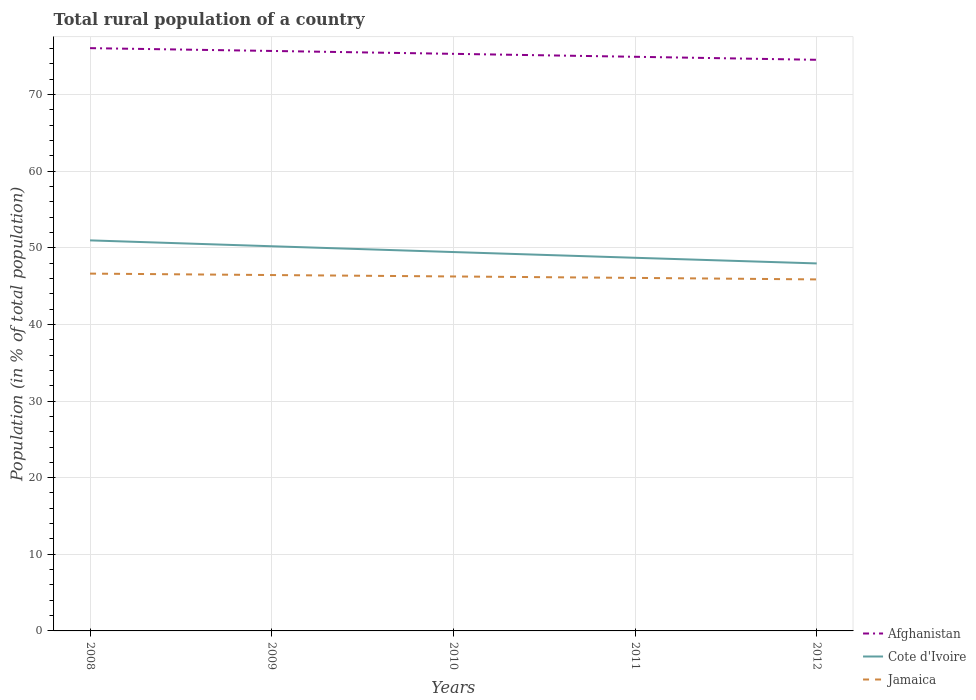How many different coloured lines are there?
Give a very brief answer. 3. Across all years, what is the maximum rural population in Jamaica?
Provide a succinct answer. 45.87. In which year was the rural population in Cote d'Ivoire maximum?
Offer a very short reply. 2012. What is the total rural population in Cote d'Ivoire in the graph?
Make the answer very short. 1.52. What is the difference between the highest and the second highest rural population in Cote d'Ivoire?
Keep it short and to the point. 3.01. Is the rural population in Cote d'Ivoire strictly greater than the rural population in Jamaica over the years?
Ensure brevity in your answer.  No. How many years are there in the graph?
Offer a terse response. 5. Are the values on the major ticks of Y-axis written in scientific E-notation?
Give a very brief answer. No. Does the graph contain grids?
Keep it short and to the point. Yes. How many legend labels are there?
Provide a succinct answer. 3. What is the title of the graph?
Ensure brevity in your answer.  Total rural population of a country. Does "Barbados" appear as one of the legend labels in the graph?
Offer a very short reply. No. What is the label or title of the X-axis?
Give a very brief answer. Years. What is the label or title of the Y-axis?
Your response must be concise. Population (in % of total population). What is the Population (in % of total population) of Afghanistan in 2008?
Give a very brief answer. 76.05. What is the Population (in % of total population) in Cote d'Ivoire in 2008?
Offer a terse response. 50.97. What is the Population (in % of total population) in Jamaica in 2008?
Provide a succinct answer. 46.63. What is the Population (in % of total population) of Afghanistan in 2009?
Make the answer very short. 75.69. What is the Population (in % of total population) in Cote d'Ivoire in 2009?
Keep it short and to the point. 50.2. What is the Population (in % of total population) of Jamaica in 2009?
Keep it short and to the point. 46.44. What is the Population (in % of total population) of Afghanistan in 2010?
Your answer should be very brief. 75.31. What is the Population (in % of total population) of Cote d'Ivoire in 2010?
Give a very brief answer. 49.44. What is the Population (in % of total population) of Jamaica in 2010?
Give a very brief answer. 46.26. What is the Population (in % of total population) in Afghanistan in 2011?
Offer a terse response. 74.93. What is the Population (in % of total population) in Cote d'Ivoire in 2011?
Keep it short and to the point. 48.7. What is the Population (in % of total population) of Jamaica in 2011?
Ensure brevity in your answer.  46.07. What is the Population (in % of total population) of Afghanistan in 2012?
Your response must be concise. 74.53. What is the Population (in % of total population) of Cote d'Ivoire in 2012?
Keep it short and to the point. 47.96. What is the Population (in % of total population) of Jamaica in 2012?
Give a very brief answer. 45.87. Across all years, what is the maximum Population (in % of total population) in Afghanistan?
Your answer should be compact. 76.05. Across all years, what is the maximum Population (in % of total population) in Cote d'Ivoire?
Your response must be concise. 50.97. Across all years, what is the maximum Population (in % of total population) of Jamaica?
Your answer should be compact. 46.63. Across all years, what is the minimum Population (in % of total population) of Afghanistan?
Keep it short and to the point. 74.53. Across all years, what is the minimum Population (in % of total population) of Cote d'Ivoire?
Your answer should be compact. 47.96. Across all years, what is the minimum Population (in % of total population) of Jamaica?
Provide a succinct answer. 45.87. What is the total Population (in % of total population) of Afghanistan in the graph?
Keep it short and to the point. 376.51. What is the total Population (in % of total population) of Cote d'Ivoire in the graph?
Your answer should be compact. 247.26. What is the total Population (in % of total population) of Jamaica in the graph?
Give a very brief answer. 231.27. What is the difference between the Population (in % of total population) of Afghanistan in 2008 and that in 2009?
Your response must be concise. 0.37. What is the difference between the Population (in % of total population) of Cote d'Ivoire in 2008 and that in 2009?
Make the answer very short. 0.77. What is the difference between the Population (in % of total population) of Jamaica in 2008 and that in 2009?
Make the answer very short. 0.19. What is the difference between the Population (in % of total population) in Afghanistan in 2008 and that in 2010?
Provide a succinct answer. 0.74. What is the difference between the Population (in % of total population) of Cote d'Ivoire in 2008 and that in 2010?
Ensure brevity in your answer.  1.52. What is the difference between the Population (in % of total population) in Jamaica in 2008 and that in 2010?
Your answer should be very brief. 0.37. What is the difference between the Population (in % of total population) in Afghanistan in 2008 and that in 2011?
Ensure brevity in your answer.  1.13. What is the difference between the Population (in % of total population) of Cote d'Ivoire in 2008 and that in 2011?
Offer a terse response. 2.27. What is the difference between the Population (in % of total population) of Jamaica in 2008 and that in 2011?
Your answer should be very brief. 0.56. What is the difference between the Population (in % of total population) of Afghanistan in 2008 and that in 2012?
Your answer should be compact. 1.52. What is the difference between the Population (in % of total population) in Cote d'Ivoire in 2008 and that in 2012?
Offer a terse response. 3.01. What is the difference between the Population (in % of total population) of Jamaica in 2008 and that in 2012?
Offer a terse response. 0.76. What is the difference between the Population (in % of total population) of Afghanistan in 2009 and that in 2010?
Offer a terse response. 0.38. What is the difference between the Population (in % of total population) in Cote d'Ivoire in 2009 and that in 2010?
Your answer should be very brief. 0.76. What is the difference between the Population (in % of total population) of Jamaica in 2009 and that in 2010?
Your answer should be very brief. 0.19. What is the difference between the Population (in % of total population) of Afghanistan in 2009 and that in 2011?
Provide a short and direct response. 0.76. What is the difference between the Population (in % of total population) of Cote d'Ivoire in 2009 and that in 2011?
Offer a terse response. 1.5. What is the difference between the Population (in % of total population) in Jamaica in 2009 and that in 2011?
Keep it short and to the point. 0.37. What is the difference between the Population (in % of total population) of Afghanistan in 2009 and that in 2012?
Make the answer very short. 1.16. What is the difference between the Population (in % of total population) in Cote d'Ivoire in 2009 and that in 2012?
Your answer should be very brief. 2.24. What is the difference between the Population (in % of total population) of Jamaica in 2009 and that in 2012?
Your response must be concise. 0.57. What is the difference between the Population (in % of total population) of Afghanistan in 2010 and that in 2011?
Make the answer very short. 0.39. What is the difference between the Population (in % of total population) in Cote d'Ivoire in 2010 and that in 2011?
Provide a succinct answer. 0.75. What is the difference between the Population (in % of total population) in Jamaica in 2010 and that in 2011?
Give a very brief answer. 0.19. What is the difference between the Population (in % of total population) of Afghanistan in 2010 and that in 2012?
Your response must be concise. 0.78. What is the difference between the Population (in % of total population) in Cote d'Ivoire in 2010 and that in 2012?
Provide a short and direct response. 1.48. What is the difference between the Population (in % of total population) of Jamaica in 2010 and that in 2012?
Offer a terse response. 0.38. What is the difference between the Population (in % of total population) of Afghanistan in 2011 and that in 2012?
Ensure brevity in your answer.  0.39. What is the difference between the Population (in % of total population) of Cote d'Ivoire in 2011 and that in 2012?
Offer a very short reply. 0.74. What is the difference between the Population (in % of total population) of Jamaica in 2011 and that in 2012?
Keep it short and to the point. 0.2. What is the difference between the Population (in % of total population) of Afghanistan in 2008 and the Population (in % of total population) of Cote d'Ivoire in 2009?
Offer a very short reply. 25.85. What is the difference between the Population (in % of total population) of Afghanistan in 2008 and the Population (in % of total population) of Jamaica in 2009?
Provide a short and direct response. 29.61. What is the difference between the Population (in % of total population) of Cote d'Ivoire in 2008 and the Population (in % of total population) of Jamaica in 2009?
Ensure brevity in your answer.  4.52. What is the difference between the Population (in % of total population) of Afghanistan in 2008 and the Population (in % of total population) of Cote d'Ivoire in 2010?
Your answer should be very brief. 26.61. What is the difference between the Population (in % of total population) of Afghanistan in 2008 and the Population (in % of total population) of Jamaica in 2010?
Your answer should be very brief. 29.8. What is the difference between the Population (in % of total population) in Cote d'Ivoire in 2008 and the Population (in % of total population) in Jamaica in 2010?
Your answer should be very brief. 4.71. What is the difference between the Population (in % of total population) in Afghanistan in 2008 and the Population (in % of total population) in Cote d'Ivoire in 2011?
Offer a terse response. 27.36. What is the difference between the Population (in % of total population) in Afghanistan in 2008 and the Population (in % of total population) in Jamaica in 2011?
Keep it short and to the point. 29.98. What is the difference between the Population (in % of total population) in Cote d'Ivoire in 2008 and the Population (in % of total population) in Jamaica in 2011?
Your response must be concise. 4.9. What is the difference between the Population (in % of total population) in Afghanistan in 2008 and the Population (in % of total population) in Cote d'Ivoire in 2012?
Your answer should be very brief. 28.09. What is the difference between the Population (in % of total population) of Afghanistan in 2008 and the Population (in % of total population) of Jamaica in 2012?
Keep it short and to the point. 30.18. What is the difference between the Population (in % of total population) in Cote d'Ivoire in 2008 and the Population (in % of total population) in Jamaica in 2012?
Provide a succinct answer. 5.09. What is the difference between the Population (in % of total population) of Afghanistan in 2009 and the Population (in % of total population) of Cote d'Ivoire in 2010?
Provide a short and direct response. 26.24. What is the difference between the Population (in % of total population) of Afghanistan in 2009 and the Population (in % of total population) of Jamaica in 2010?
Provide a succinct answer. 29.43. What is the difference between the Population (in % of total population) in Cote d'Ivoire in 2009 and the Population (in % of total population) in Jamaica in 2010?
Offer a very short reply. 3.94. What is the difference between the Population (in % of total population) in Afghanistan in 2009 and the Population (in % of total population) in Cote d'Ivoire in 2011?
Offer a very short reply. 26.99. What is the difference between the Population (in % of total population) of Afghanistan in 2009 and the Population (in % of total population) of Jamaica in 2011?
Your answer should be very brief. 29.62. What is the difference between the Population (in % of total population) of Cote d'Ivoire in 2009 and the Population (in % of total population) of Jamaica in 2011?
Give a very brief answer. 4.13. What is the difference between the Population (in % of total population) of Afghanistan in 2009 and the Population (in % of total population) of Cote d'Ivoire in 2012?
Offer a very short reply. 27.73. What is the difference between the Population (in % of total population) of Afghanistan in 2009 and the Population (in % of total population) of Jamaica in 2012?
Offer a very short reply. 29.81. What is the difference between the Population (in % of total population) in Cote d'Ivoire in 2009 and the Population (in % of total population) in Jamaica in 2012?
Keep it short and to the point. 4.33. What is the difference between the Population (in % of total population) of Afghanistan in 2010 and the Population (in % of total population) of Cote d'Ivoire in 2011?
Your response must be concise. 26.62. What is the difference between the Population (in % of total population) of Afghanistan in 2010 and the Population (in % of total population) of Jamaica in 2011?
Keep it short and to the point. 29.24. What is the difference between the Population (in % of total population) in Cote d'Ivoire in 2010 and the Population (in % of total population) in Jamaica in 2011?
Provide a short and direct response. 3.37. What is the difference between the Population (in % of total population) in Afghanistan in 2010 and the Population (in % of total population) in Cote d'Ivoire in 2012?
Provide a succinct answer. 27.35. What is the difference between the Population (in % of total population) in Afghanistan in 2010 and the Population (in % of total population) in Jamaica in 2012?
Your answer should be compact. 29.44. What is the difference between the Population (in % of total population) of Cote d'Ivoire in 2010 and the Population (in % of total population) of Jamaica in 2012?
Offer a very short reply. 3.57. What is the difference between the Population (in % of total population) of Afghanistan in 2011 and the Population (in % of total population) of Cote d'Ivoire in 2012?
Make the answer very short. 26.97. What is the difference between the Population (in % of total population) in Afghanistan in 2011 and the Population (in % of total population) in Jamaica in 2012?
Your answer should be very brief. 29.05. What is the difference between the Population (in % of total population) of Cote d'Ivoire in 2011 and the Population (in % of total population) of Jamaica in 2012?
Your answer should be compact. 2.82. What is the average Population (in % of total population) of Afghanistan per year?
Offer a very short reply. 75.3. What is the average Population (in % of total population) of Cote d'Ivoire per year?
Offer a very short reply. 49.45. What is the average Population (in % of total population) of Jamaica per year?
Make the answer very short. 46.25. In the year 2008, what is the difference between the Population (in % of total population) in Afghanistan and Population (in % of total population) in Cote d'Ivoire?
Make the answer very short. 25.09. In the year 2008, what is the difference between the Population (in % of total population) of Afghanistan and Population (in % of total population) of Jamaica?
Keep it short and to the point. 29.43. In the year 2008, what is the difference between the Population (in % of total population) of Cote d'Ivoire and Population (in % of total population) of Jamaica?
Give a very brief answer. 4.34. In the year 2009, what is the difference between the Population (in % of total population) in Afghanistan and Population (in % of total population) in Cote d'Ivoire?
Provide a succinct answer. 25.49. In the year 2009, what is the difference between the Population (in % of total population) of Afghanistan and Population (in % of total population) of Jamaica?
Make the answer very short. 29.24. In the year 2009, what is the difference between the Population (in % of total population) of Cote d'Ivoire and Population (in % of total population) of Jamaica?
Offer a very short reply. 3.76. In the year 2010, what is the difference between the Population (in % of total population) of Afghanistan and Population (in % of total population) of Cote d'Ivoire?
Provide a short and direct response. 25.87. In the year 2010, what is the difference between the Population (in % of total population) of Afghanistan and Population (in % of total population) of Jamaica?
Your response must be concise. 29.05. In the year 2010, what is the difference between the Population (in % of total population) of Cote d'Ivoire and Population (in % of total population) of Jamaica?
Offer a terse response. 3.19. In the year 2011, what is the difference between the Population (in % of total population) of Afghanistan and Population (in % of total population) of Cote d'Ivoire?
Ensure brevity in your answer.  26.23. In the year 2011, what is the difference between the Population (in % of total population) in Afghanistan and Population (in % of total population) in Jamaica?
Your response must be concise. 28.86. In the year 2011, what is the difference between the Population (in % of total population) in Cote d'Ivoire and Population (in % of total population) in Jamaica?
Your response must be concise. 2.62. In the year 2012, what is the difference between the Population (in % of total population) of Afghanistan and Population (in % of total population) of Cote d'Ivoire?
Ensure brevity in your answer.  26.57. In the year 2012, what is the difference between the Population (in % of total population) of Afghanistan and Population (in % of total population) of Jamaica?
Provide a short and direct response. 28.66. In the year 2012, what is the difference between the Population (in % of total population) of Cote d'Ivoire and Population (in % of total population) of Jamaica?
Provide a succinct answer. 2.09. What is the ratio of the Population (in % of total population) of Cote d'Ivoire in 2008 to that in 2009?
Provide a short and direct response. 1.02. What is the ratio of the Population (in % of total population) of Jamaica in 2008 to that in 2009?
Your answer should be compact. 1. What is the ratio of the Population (in % of total population) of Afghanistan in 2008 to that in 2010?
Your response must be concise. 1.01. What is the ratio of the Population (in % of total population) in Cote d'Ivoire in 2008 to that in 2010?
Give a very brief answer. 1.03. What is the ratio of the Population (in % of total population) in Jamaica in 2008 to that in 2010?
Provide a succinct answer. 1.01. What is the ratio of the Population (in % of total population) of Afghanistan in 2008 to that in 2011?
Provide a succinct answer. 1.02. What is the ratio of the Population (in % of total population) of Cote d'Ivoire in 2008 to that in 2011?
Offer a very short reply. 1.05. What is the ratio of the Population (in % of total population) in Jamaica in 2008 to that in 2011?
Keep it short and to the point. 1.01. What is the ratio of the Population (in % of total population) in Afghanistan in 2008 to that in 2012?
Your answer should be compact. 1.02. What is the ratio of the Population (in % of total population) in Cote d'Ivoire in 2008 to that in 2012?
Your answer should be very brief. 1.06. What is the ratio of the Population (in % of total population) in Jamaica in 2008 to that in 2012?
Ensure brevity in your answer.  1.02. What is the ratio of the Population (in % of total population) in Cote d'Ivoire in 2009 to that in 2010?
Provide a short and direct response. 1.02. What is the ratio of the Population (in % of total population) of Afghanistan in 2009 to that in 2011?
Your answer should be compact. 1.01. What is the ratio of the Population (in % of total population) in Cote d'Ivoire in 2009 to that in 2011?
Your answer should be compact. 1.03. What is the ratio of the Population (in % of total population) of Jamaica in 2009 to that in 2011?
Provide a succinct answer. 1.01. What is the ratio of the Population (in % of total population) in Afghanistan in 2009 to that in 2012?
Your response must be concise. 1.02. What is the ratio of the Population (in % of total population) of Cote d'Ivoire in 2009 to that in 2012?
Your answer should be compact. 1.05. What is the ratio of the Population (in % of total population) in Jamaica in 2009 to that in 2012?
Offer a very short reply. 1.01. What is the ratio of the Population (in % of total population) of Afghanistan in 2010 to that in 2011?
Offer a terse response. 1.01. What is the ratio of the Population (in % of total population) of Cote d'Ivoire in 2010 to that in 2011?
Provide a short and direct response. 1.02. What is the ratio of the Population (in % of total population) in Afghanistan in 2010 to that in 2012?
Offer a very short reply. 1.01. What is the ratio of the Population (in % of total population) of Cote d'Ivoire in 2010 to that in 2012?
Your answer should be very brief. 1.03. What is the ratio of the Population (in % of total population) in Jamaica in 2010 to that in 2012?
Your answer should be very brief. 1.01. What is the ratio of the Population (in % of total population) in Afghanistan in 2011 to that in 2012?
Offer a terse response. 1.01. What is the ratio of the Population (in % of total population) in Cote d'Ivoire in 2011 to that in 2012?
Make the answer very short. 1.02. What is the ratio of the Population (in % of total population) in Jamaica in 2011 to that in 2012?
Your response must be concise. 1. What is the difference between the highest and the second highest Population (in % of total population) in Afghanistan?
Ensure brevity in your answer.  0.37. What is the difference between the highest and the second highest Population (in % of total population) in Cote d'Ivoire?
Offer a terse response. 0.77. What is the difference between the highest and the second highest Population (in % of total population) in Jamaica?
Offer a very short reply. 0.19. What is the difference between the highest and the lowest Population (in % of total population) of Afghanistan?
Give a very brief answer. 1.52. What is the difference between the highest and the lowest Population (in % of total population) in Cote d'Ivoire?
Your response must be concise. 3.01. What is the difference between the highest and the lowest Population (in % of total population) of Jamaica?
Keep it short and to the point. 0.76. 